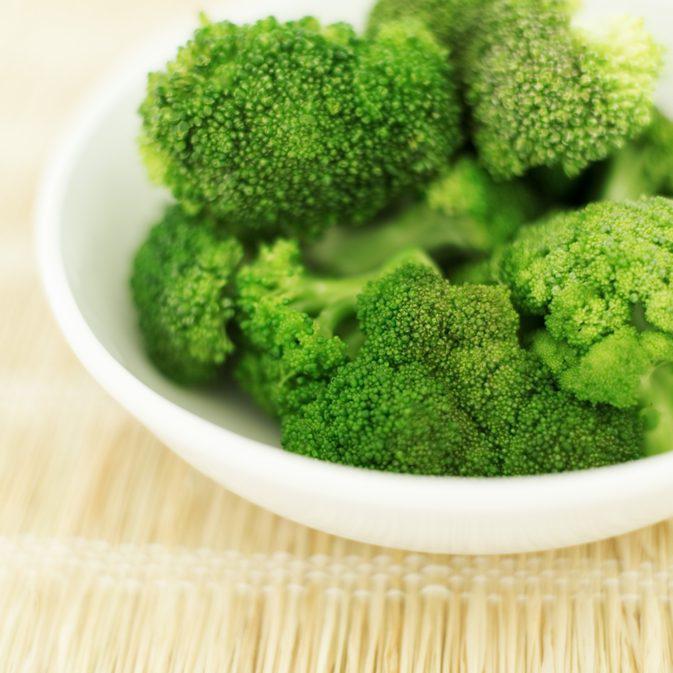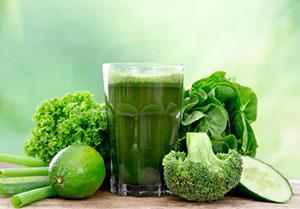The first image is the image on the left, the second image is the image on the right. Considering the images on both sides, is "A total of three cut broccoli florets are shown." valid? Answer yes or no. No. 